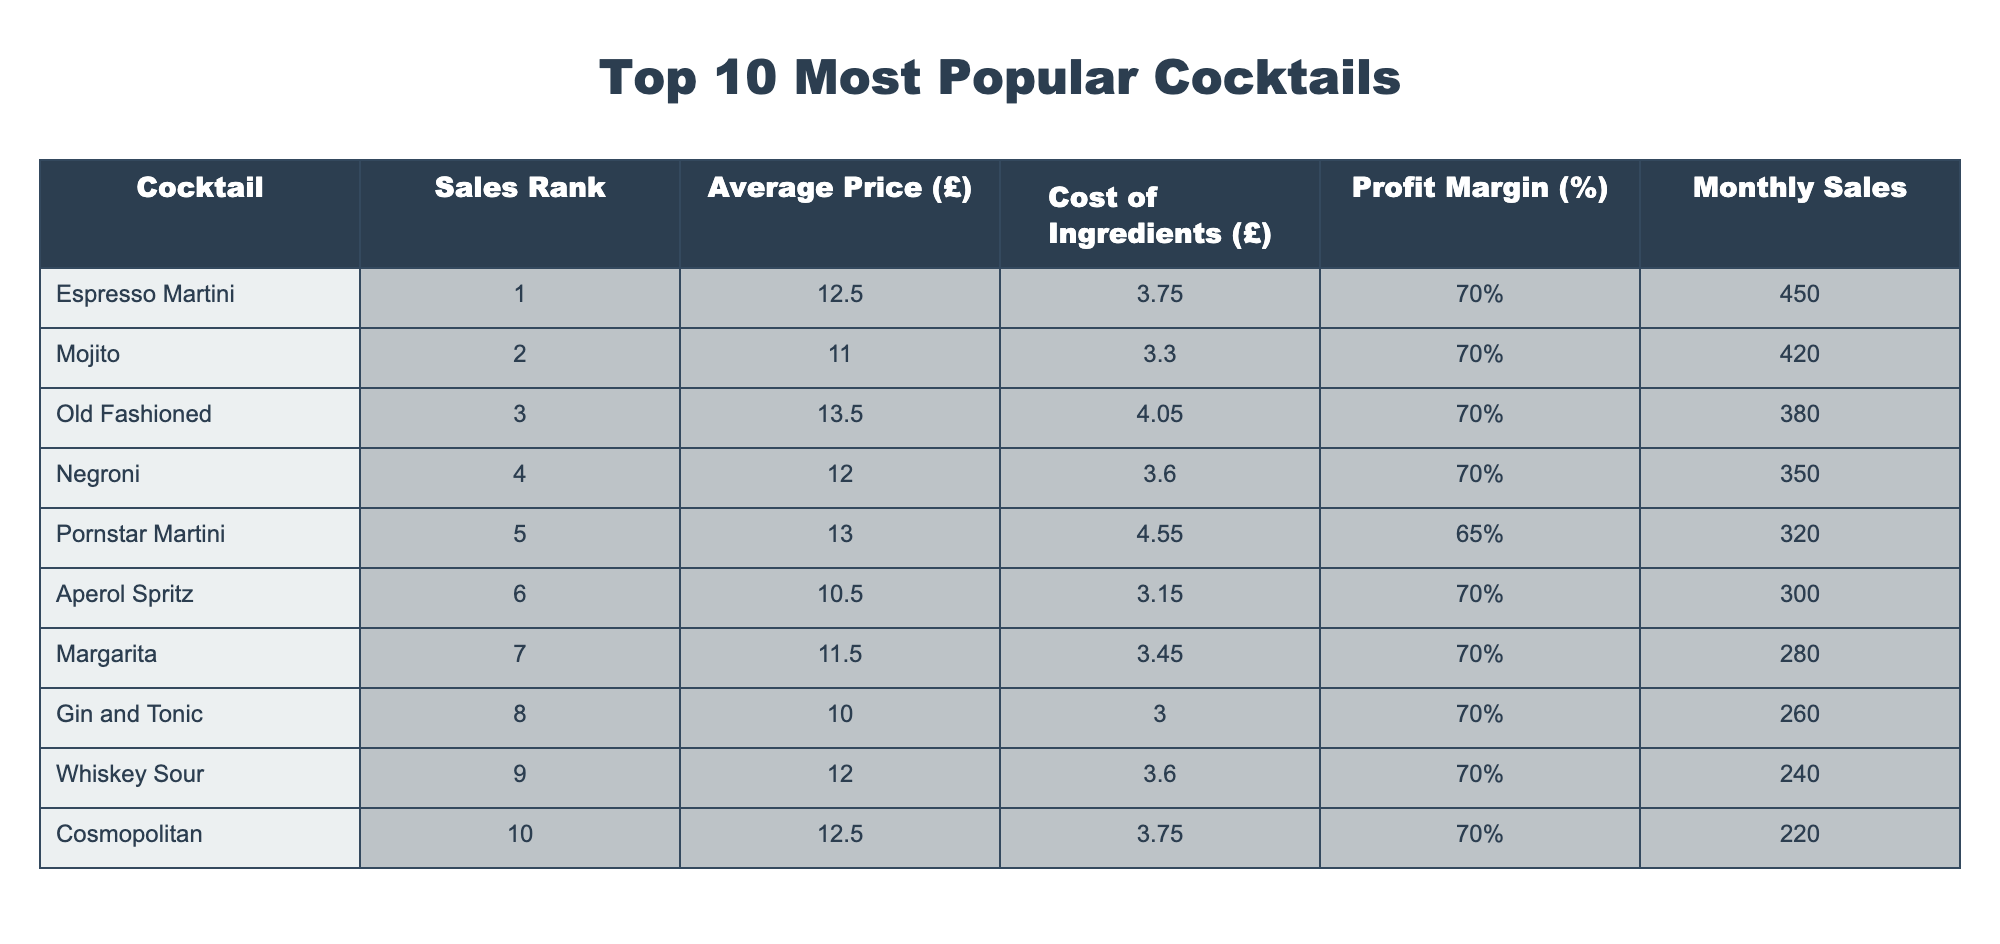What is the profit margin of the Old Fashioned cocktail? According to the table, the Old Fashioned has a profit margin listed under the Profit Margin (%) column. Checking the value, it shows 70%.
Answer: 70% Which cocktail has the highest average price? Looking through the Average Price (£) column, we can see that the Old Fashioned has an average price of £13.50, which is the highest among all cocktails listed.
Answer: Old Fashioned How much profit does the Espresso Martini generate per sale? To find the profit per sale for the Espresso Martini, we need to calculate it using the average price (£12.50) and the cost of ingredients (£3.75). The profit per sale is £12.50 - £3.75 = £8.75.
Answer: £8.75 Which cocktail has the lowest profit margin? By reviewing the Profit Margin (%) column, we see that the Pornstar Martini has a profit margin of 65%, which is lower than all the other cocktails.
Answer: Pornstar Martini What is the total monthly sales volume for all cocktails? To find the total monthly sales, we need to add the Monthly Sales for each cocktail: 450 + 420 + 380 + 350 + 320 + 300 + 280 + 260 + 240 + 220 = 3,920. Therefore, the total monthly sales volume is £3,920.
Answer: £3,920 Is the average price of the Mojito greater than £11? Checking the Average Price (£) column for the Mojito, it shows £11.00, which is not greater than £11. Therefore, the answer is no.
Answer: No What is the average profit margin of the top 5 cocktails? The profit margins of the top 5 cocktails are 70%, 70%, 70%, 70%, and 65%. To get the average, we add them up (70 + 70 + 70 + 70 + 65) = 345 and divide by 5: 345 / 5 = 69%. Hence, the average profit margin of the top 5 cocktails is 69%.
Answer: 69% Which two cocktails have the same profit margin percentage? By examining the Profit Margin (%) column, we see that the Espresso Martini, Mojito, Old Fashioned, Negroni, Aperol Spritz, Margarita, Gin and Tonic, Whiskey Sour, and Cosmopolitan all have a profit margin of 70%. The answer is these cocktails share the same percentage.
Answer: Espresso Martini, Mojito, Old Fashioned, Negroni, Aperol Spritz, Margarita, Gin and Tonic, Whiskey Sour, Cosmopolitan How many cocktails have a monthly sales figure above 300? Reviewing the Monthly Sales figure, we find that the cocktails with sales above 300 are Espresso Martini (450), Mojito (420), Old Fashioned (380), Pornstar Martini (320), and Aperol Spritz (300). Counting these, there are 5 cocktails.
Answer: 5 